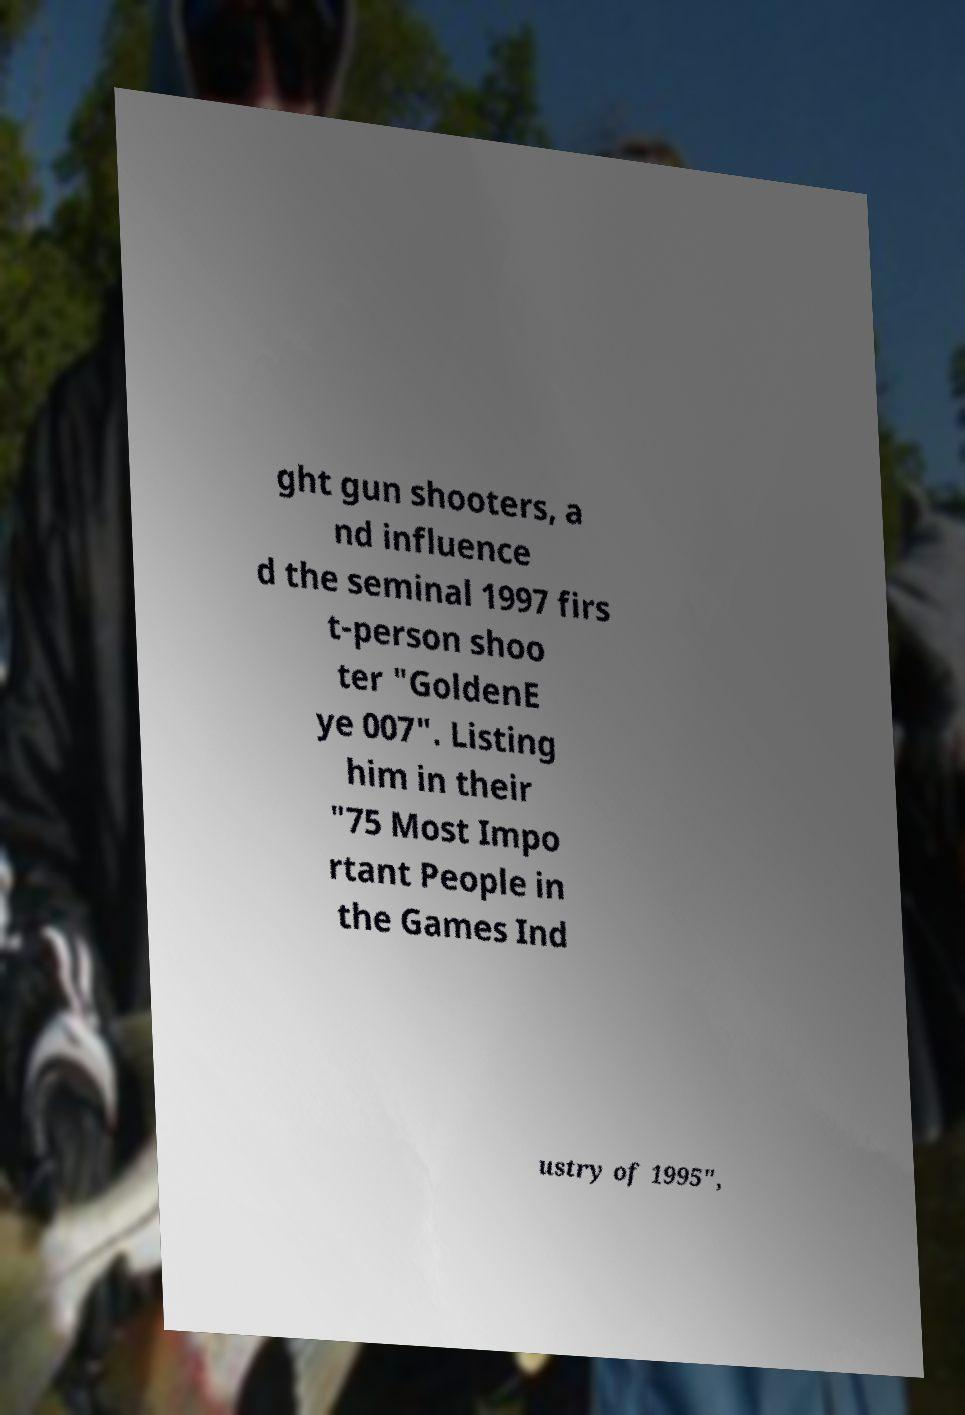Can you accurately transcribe the text from the provided image for me? ght gun shooters, a nd influence d the seminal 1997 firs t-person shoo ter "GoldenE ye 007". Listing him in their "75 Most Impo rtant People in the Games Ind ustry of 1995", 